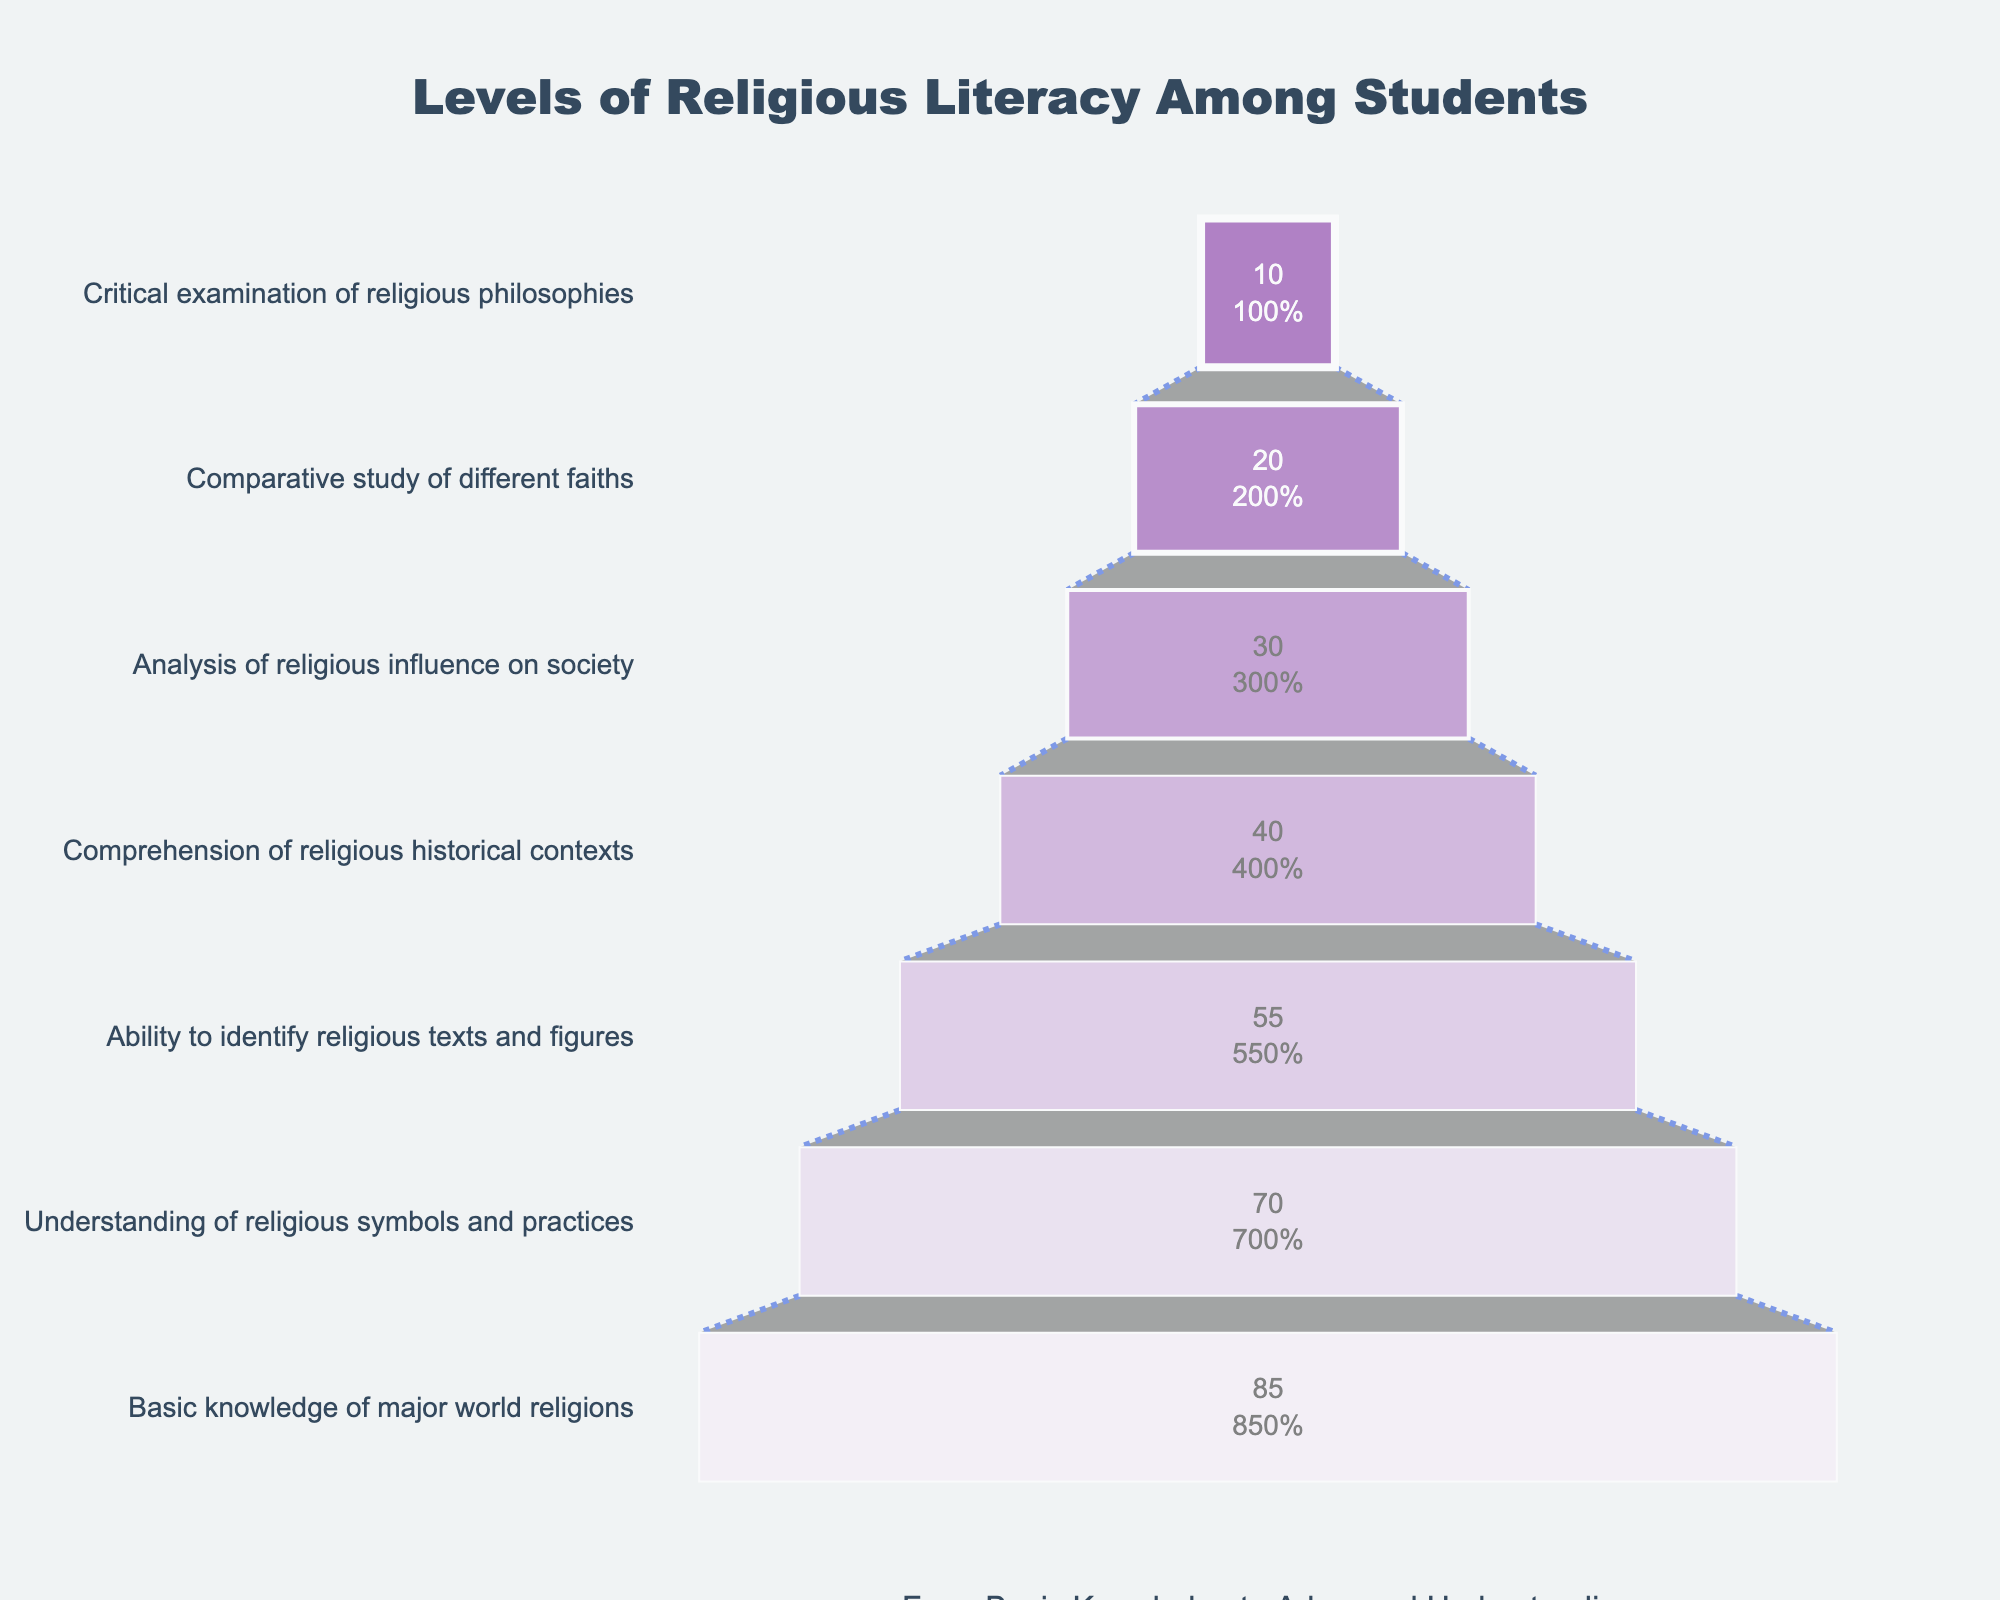What is the title of the chart? The title is prominently displayed at the top of the chart.
Answer: Levels of Religious Literacy Among Students What percentage of students have a basic knowledge of major world religions? Directly refer to the first stage of the funnel chart to find the corresponding percentage.
Answer: 85% What is the difference in percentage between students who understand religious symbols and practices and those who can identify religious texts and figures? Subtract the percentage of the lower stage from the percentage of the higher stage: 70% - 55% = 15%.
Answer: 15% Which level has the lowest percentage of students? Look at the funnel chart to identify the stage with the smallest percentage.
Answer: Critical examination of religious philosophies What is the combined percentage of students who can comprehend religious historical contexts and those who can analyze the religious influence on society? Add the percentages of both stages: 40% (Comprehension of religious historical contexts) + 30% (Analysis of religious influence on society) = 70%.
Answer: 70% How do the percentages of students who can conduct a comparative study of different faiths and those who can critically examine religious philosophies compare? Refer to the funnel chart to see that the numbers are 20% and 10%, respectively. 20% > 10%.
Answer: More students can conduct a comparative study of different faiths than can critically examine religious philosophies What percentage of students have advanced understanding beyond the basic knowledge of major world religions? Since the basic level is 85%, add up the percentages of all other stages to find the combined percentage of advanced understanding. 70% + 55% + 40% + 30% + 20% + 10% = 225%.
Answer: 225% What is the average percentage of students across all levels of religious literacy? Calculate the average by summing the percentages of all seven levels and dividing by 7: (85 + 70 + 55 + 40 + 30 + 20 + 10) / 7 ≈ 44.29%.
Answer: 44.29% Which stage shows the greatest drop in percentage compared to the previous stage? Compare the differences between consecutive levels. The drop from "Comparative study of different faiths" to "Critical examination of religious philosophies" is the largest: 20% - 10% = 10%.
Answer: From "Comparative study of different faiths" to "Critical examination of religious philosophies" How does comprehension of religious historical contexts compare to the ability to identify religious texts and figures? Compare their percentages: 40% for historical contexts and 55% for identifying texts and figures. 55% > 40%.
Answer: Fewer students comprehend religious historical contexts compared to identifying religious texts and figures 